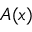Convert formula to latex. <formula><loc_0><loc_0><loc_500><loc_500>A ( x )</formula> 